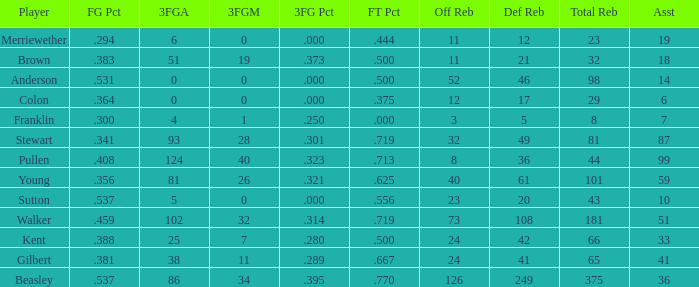I'm looking to parse the entire table for insights. Could you assist me with that? {'header': ['Player', 'FG Pct', '3FGA', '3FGM', '3FG Pct', 'FT Pct', 'Off Reb', 'Def Reb', 'Total Reb', 'Asst'], 'rows': [['Merriewether', '.294', '6', '0', '.000', '.444', '11', '12', '23', '19'], ['Brown', '.383', '51', '19', '.373', '.500', '11', '21', '32', '18'], ['Anderson', '.531', '0', '0', '.000', '.500', '52', '46', '98', '14'], ['Colon', '.364', '0', '0', '.000', '.375', '12', '17', '29', '6'], ['Franklin', '.300', '4', '1', '.250', '.000', '3', '5', '8', '7'], ['Stewart', '.341', '93', '28', '.301', '.719', '32', '49', '81', '87'], ['Pullen', '.408', '124', '40', '.323', '.713', '8', '36', '44', '99'], ['Young', '.356', '81', '26', '.321', '.625', '40', '61', '101', '59'], ['Sutton', '.537', '5', '0', '.000', '.556', '23', '20', '43', '10'], ['Walker', '.459', '102', '32', '.314', '.719', '73', '108', '181', '51'], ['Kent', '.388', '25', '7', '.280', '.500', '24', '42', '66', '33'], ['Gilbert', '.381', '38', '11', '.289', '.667', '24', '41', '65', '41'], ['Beasley', '.537', '86', '34', '.395', '.770', '126', '249', '375', '36']]} What is the total number of offensive rebounds for players with more than 124 3-point attempts? 0.0. 